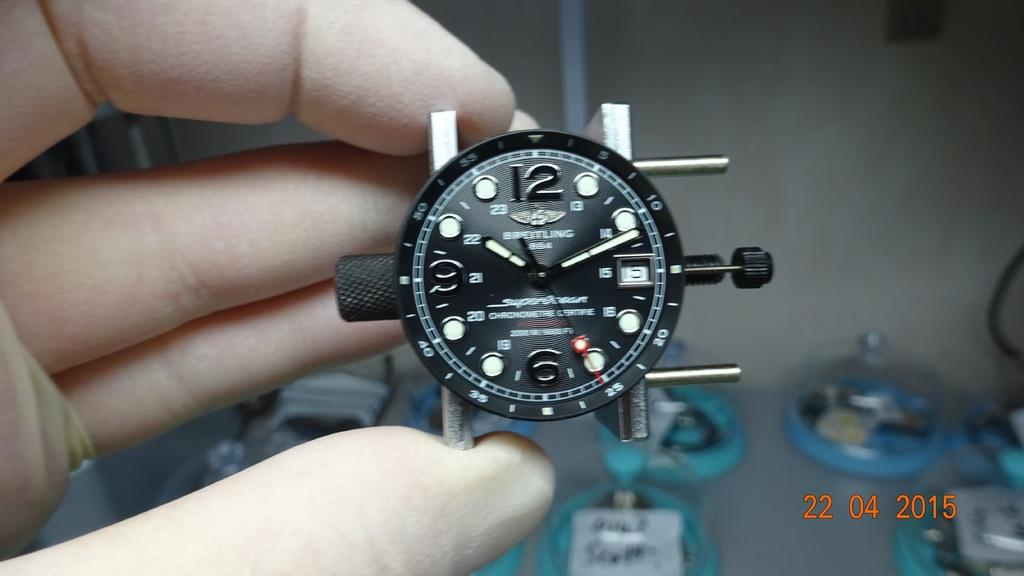<image>
Give a short and clear explanation of the subsequent image. A man is holding a black watch face that has the number 12 on it. 